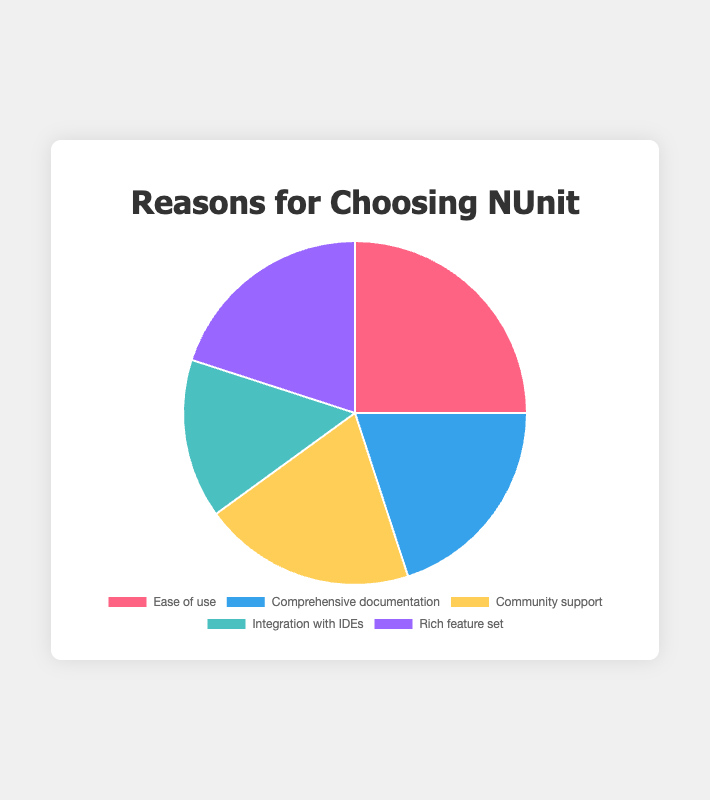What is the most common reason for choosing NUnit among the given options? To determine which reason is the most common, look for the data point with the highest value in the pie chart. "Ease of use" has the highest percentage at 25%.
Answer: Ease of use Which reasons have equal percentages in the pie chart? By examining the pie chart, observe the segments of the pie that have the same size. "Comprehensive documentation," "Community support," and "Rich feature set" each account for 20%.
Answer: Comprehensive documentation, Community support, Rich feature set Which reason has the smallest percentage in the pie chart? Identify the data point with the lowest value by comparing the sizes of each segment in the pie chart. "Integration with IDEs" has the smallest percentage at 15%.
Answer: Integration with IDEs What is the total percentage represented by the "Community support" and "Rich feature set" combined? Add the percentages of "Community support" and "Rich feature set": 20% (Community support) + 20% (Rich feature set) = 40%.
Answer: 40% Are the percentages of "Comprehensive documentation" and "Community support" greater than "Ease of use"? Add "Comprehensive documentation" (20%) and "Community support" (20%). Their combined percentage is 40%, which is greater than "Ease of use" at 25%.
Answer: Yes What's the average percentage of the reasons excluding "Ease of use"? Sum the percentages of "Comprehensive documentation," "Community support," "Integration with IDEs," and "Rich feature set": 20% + 20% + 15% + 20% = 75%. Then, divide by 4 (since there are 4 data points): 75% / 4 = 18.75%.
Answer: 18.75% What percentage is represented by all reasons other than "Integration with IDEs"? Subtract the percentage for "Integration with IDEs" from the total percentage (100%): 100% - 15% = 85%.
Answer: 85% Which color represents "Rich feature set" in the pie chart? Look at the legend and match "Rich feature set" to its corresponding color. "Rich feature set" is represented by purple.
Answer: Purple 